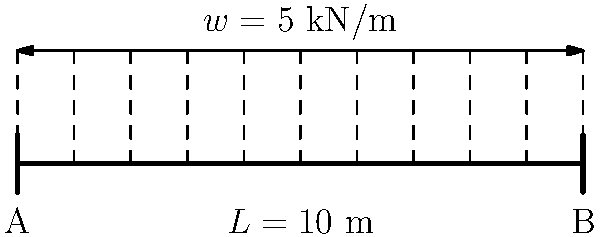As a fitness coach who understands the importance of structural integrity in gym equipment, consider a simply supported bridge beam with a span of 10 meters subjected to a uniformly distributed load of 5 kN/m along its entire length. Determine the maximum shear force and bending moment in the beam. How might this analysis relate to ensuring the safety of heavy gym equipment? Let's approach this step-by-step:

1) First, calculate the total load on the beam:
   $$W = w \times L = 5 \text{ kN/m} \times 10 \text{ m} = 50 \text{ kN}$$

2) For a simply supported beam with a uniformly distributed load, the reactions at both supports are equal:
   $$R_A = R_B = \frac{W}{2} = \frac{50 \text{ kN}}{2} = 25 \text{ kN}$$

3) The shear force diagram is linear, with maximum values at the supports:
   $$V_{max} = R_A = R_B = 25 \text{ kN}$$

4) The bending moment diagram is parabolic. The maximum bending moment occurs at the middle of the beam:
   $$M_{max} = \frac{wL^2}{8} = \frac{5 \text{ kN/m} \times (10 \text{ m})^2}{8} = 62.5 \text{ kN·m}$$

This analysis is crucial for ensuring the safety of gym equipment. Just as a bridge must withstand distributed loads, heavy gym equipment like squat racks or weight benches must be designed to handle distributed loads from various exercises. Understanding load distribution helps in designing equipment that can safely support the maximum weight a user might lift, ensuring durability and preventing accidents.
Answer: $V_{max} = 25 \text{ kN}$, $M_{max} = 62.5 \text{ kN·m}$ 